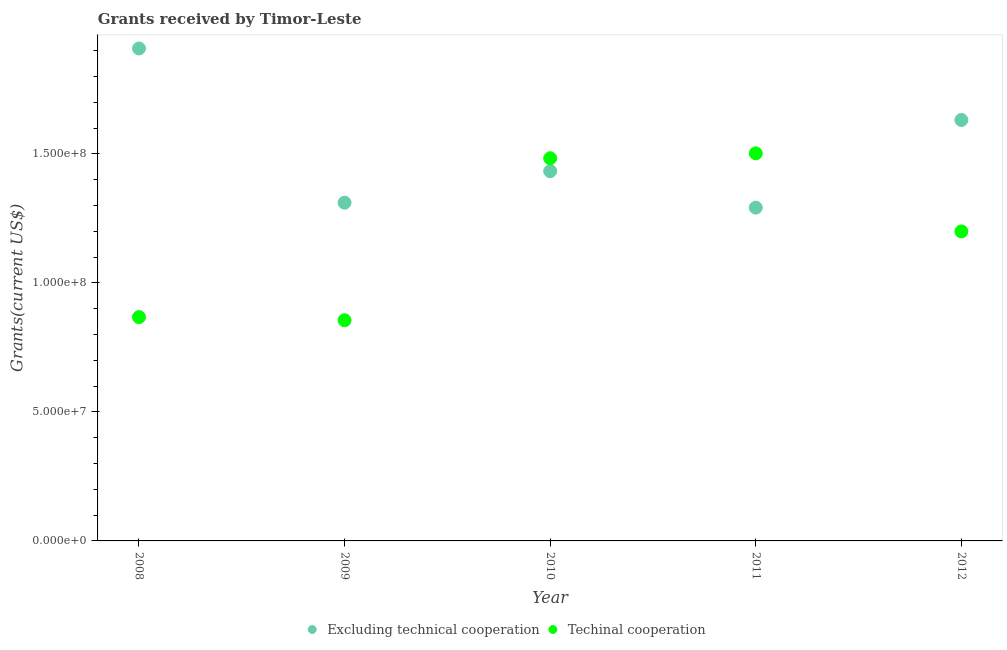Is the number of dotlines equal to the number of legend labels?
Your response must be concise. Yes. What is the amount of grants received(including technical cooperation) in 2011?
Ensure brevity in your answer.  1.50e+08. Across all years, what is the maximum amount of grants received(excluding technical cooperation)?
Offer a very short reply. 1.91e+08. Across all years, what is the minimum amount of grants received(including technical cooperation)?
Give a very brief answer. 8.55e+07. In which year was the amount of grants received(excluding technical cooperation) minimum?
Provide a short and direct response. 2011. What is the total amount of grants received(excluding technical cooperation) in the graph?
Offer a terse response. 7.57e+08. What is the difference between the amount of grants received(including technical cooperation) in 2008 and that in 2011?
Provide a succinct answer. -6.34e+07. What is the difference between the amount of grants received(including technical cooperation) in 2010 and the amount of grants received(excluding technical cooperation) in 2009?
Your answer should be compact. 1.72e+07. What is the average amount of grants received(including technical cooperation) per year?
Ensure brevity in your answer.  1.18e+08. In the year 2008, what is the difference between the amount of grants received(excluding technical cooperation) and amount of grants received(including technical cooperation)?
Keep it short and to the point. 1.04e+08. In how many years, is the amount of grants received(including technical cooperation) greater than 80000000 US$?
Offer a terse response. 5. What is the ratio of the amount of grants received(excluding technical cooperation) in 2008 to that in 2012?
Offer a terse response. 1.17. Is the amount of grants received(excluding technical cooperation) in 2008 less than that in 2011?
Make the answer very short. No. Is the difference between the amount of grants received(including technical cooperation) in 2009 and 2010 greater than the difference between the amount of grants received(excluding technical cooperation) in 2009 and 2010?
Your answer should be compact. No. What is the difference between the highest and the second highest amount of grants received(excluding technical cooperation)?
Provide a short and direct response. 2.77e+07. What is the difference between the highest and the lowest amount of grants received(excluding technical cooperation)?
Offer a very short reply. 6.17e+07. In how many years, is the amount of grants received(including technical cooperation) greater than the average amount of grants received(including technical cooperation) taken over all years?
Your response must be concise. 3. Does the amount of grants received(excluding technical cooperation) monotonically increase over the years?
Ensure brevity in your answer.  No. Is the amount of grants received(excluding technical cooperation) strictly less than the amount of grants received(including technical cooperation) over the years?
Your response must be concise. No. How many dotlines are there?
Provide a succinct answer. 2. How many years are there in the graph?
Your answer should be very brief. 5. Does the graph contain grids?
Your answer should be compact. No. Where does the legend appear in the graph?
Give a very brief answer. Bottom center. How are the legend labels stacked?
Provide a short and direct response. Horizontal. What is the title of the graph?
Provide a succinct answer. Grants received by Timor-Leste. What is the label or title of the Y-axis?
Provide a short and direct response. Grants(current US$). What is the Grants(current US$) of Excluding technical cooperation in 2008?
Provide a short and direct response. 1.91e+08. What is the Grants(current US$) in Techinal cooperation in 2008?
Make the answer very short. 8.67e+07. What is the Grants(current US$) in Excluding technical cooperation in 2009?
Offer a terse response. 1.31e+08. What is the Grants(current US$) in Techinal cooperation in 2009?
Ensure brevity in your answer.  8.55e+07. What is the Grants(current US$) of Excluding technical cooperation in 2010?
Your response must be concise. 1.43e+08. What is the Grants(current US$) of Techinal cooperation in 2010?
Offer a terse response. 1.48e+08. What is the Grants(current US$) of Excluding technical cooperation in 2011?
Keep it short and to the point. 1.29e+08. What is the Grants(current US$) of Techinal cooperation in 2011?
Make the answer very short. 1.50e+08. What is the Grants(current US$) of Excluding technical cooperation in 2012?
Provide a succinct answer. 1.63e+08. What is the Grants(current US$) of Techinal cooperation in 2012?
Give a very brief answer. 1.20e+08. Across all years, what is the maximum Grants(current US$) of Excluding technical cooperation?
Provide a short and direct response. 1.91e+08. Across all years, what is the maximum Grants(current US$) in Techinal cooperation?
Offer a terse response. 1.50e+08. Across all years, what is the minimum Grants(current US$) of Excluding technical cooperation?
Your answer should be very brief. 1.29e+08. Across all years, what is the minimum Grants(current US$) of Techinal cooperation?
Your response must be concise. 8.55e+07. What is the total Grants(current US$) in Excluding technical cooperation in the graph?
Your response must be concise. 7.57e+08. What is the total Grants(current US$) in Techinal cooperation in the graph?
Provide a short and direct response. 5.91e+08. What is the difference between the Grants(current US$) in Excluding technical cooperation in 2008 and that in 2009?
Provide a short and direct response. 5.98e+07. What is the difference between the Grants(current US$) in Techinal cooperation in 2008 and that in 2009?
Offer a very short reply. 1.21e+06. What is the difference between the Grants(current US$) in Excluding technical cooperation in 2008 and that in 2010?
Offer a very short reply. 4.75e+07. What is the difference between the Grants(current US$) of Techinal cooperation in 2008 and that in 2010?
Ensure brevity in your answer.  -6.16e+07. What is the difference between the Grants(current US$) in Excluding technical cooperation in 2008 and that in 2011?
Offer a very short reply. 6.17e+07. What is the difference between the Grants(current US$) in Techinal cooperation in 2008 and that in 2011?
Give a very brief answer. -6.34e+07. What is the difference between the Grants(current US$) of Excluding technical cooperation in 2008 and that in 2012?
Your response must be concise. 2.77e+07. What is the difference between the Grants(current US$) in Techinal cooperation in 2008 and that in 2012?
Your response must be concise. -3.32e+07. What is the difference between the Grants(current US$) of Excluding technical cooperation in 2009 and that in 2010?
Provide a short and direct response. -1.22e+07. What is the difference between the Grants(current US$) of Techinal cooperation in 2009 and that in 2010?
Offer a terse response. -6.28e+07. What is the difference between the Grants(current US$) of Excluding technical cooperation in 2009 and that in 2011?
Your response must be concise. 1.91e+06. What is the difference between the Grants(current US$) in Techinal cooperation in 2009 and that in 2011?
Offer a terse response. -6.47e+07. What is the difference between the Grants(current US$) of Excluding technical cooperation in 2009 and that in 2012?
Make the answer very short. -3.20e+07. What is the difference between the Grants(current US$) of Techinal cooperation in 2009 and that in 2012?
Your answer should be compact. -3.44e+07. What is the difference between the Grants(current US$) in Excluding technical cooperation in 2010 and that in 2011?
Ensure brevity in your answer.  1.41e+07. What is the difference between the Grants(current US$) in Techinal cooperation in 2010 and that in 2011?
Offer a terse response. -1.90e+06. What is the difference between the Grants(current US$) of Excluding technical cooperation in 2010 and that in 2012?
Your answer should be very brief. -1.98e+07. What is the difference between the Grants(current US$) in Techinal cooperation in 2010 and that in 2012?
Make the answer very short. 2.83e+07. What is the difference between the Grants(current US$) of Excluding technical cooperation in 2011 and that in 2012?
Your answer should be very brief. -3.40e+07. What is the difference between the Grants(current US$) of Techinal cooperation in 2011 and that in 2012?
Provide a short and direct response. 3.02e+07. What is the difference between the Grants(current US$) of Excluding technical cooperation in 2008 and the Grants(current US$) of Techinal cooperation in 2009?
Give a very brief answer. 1.05e+08. What is the difference between the Grants(current US$) of Excluding technical cooperation in 2008 and the Grants(current US$) of Techinal cooperation in 2010?
Ensure brevity in your answer.  4.26e+07. What is the difference between the Grants(current US$) of Excluding technical cooperation in 2008 and the Grants(current US$) of Techinal cooperation in 2011?
Offer a terse response. 4.06e+07. What is the difference between the Grants(current US$) in Excluding technical cooperation in 2008 and the Grants(current US$) in Techinal cooperation in 2012?
Offer a very short reply. 7.09e+07. What is the difference between the Grants(current US$) of Excluding technical cooperation in 2009 and the Grants(current US$) of Techinal cooperation in 2010?
Your response must be concise. -1.72e+07. What is the difference between the Grants(current US$) of Excluding technical cooperation in 2009 and the Grants(current US$) of Techinal cooperation in 2011?
Provide a succinct answer. -1.91e+07. What is the difference between the Grants(current US$) in Excluding technical cooperation in 2009 and the Grants(current US$) in Techinal cooperation in 2012?
Your response must be concise. 1.11e+07. What is the difference between the Grants(current US$) in Excluding technical cooperation in 2010 and the Grants(current US$) in Techinal cooperation in 2011?
Your answer should be very brief. -6.89e+06. What is the difference between the Grants(current US$) of Excluding technical cooperation in 2010 and the Grants(current US$) of Techinal cooperation in 2012?
Make the answer very short. 2.34e+07. What is the difference between the Grants(current US$) in Excluding technical cooperation in 2011 and the Grants(current US$) in Techinal cooperation in 2012?
Your answer should be very brief. 9.22e+06. What is the average Grants(current US$) of Excluding technical cooperation per year?
Offer a terse response. 1.51e+08. What is the average Grants(current US$) in Techinal cooperation per year?
Your answer should be very brief. 1.18e+08. In the year 2008, what is the difference between the Grants(current US$) in Excluding technical cooperation and Grants(current US$) in Techinal cooperation?
Provide a succinct answer. 1.04e+08. In the year 2009, what is the difference between the Grants(current US$) in Excluding technical cooperation and Grants(current US$) in Techinal cooperation?
Your answer should be compact. 4.56e+07. In the year 2010, what is the difference between the Grants(current US$) in Excluding technical cooperation and Grants(current US$) in Techinal cooperation?
Make the answer very short. -4.99e+06. In the year 2011, what is the difference between the Grants(current US$) in Excluding technical cooperation and Grants(current US$) in Techinal cooperation?
Give a very brief answer. -2.10e+07. In the year 2012, what is the difference between the Grants(current US$) of Excluding technical cooperation and Grants(current US$) of Techinal cooperation?
Make the answer very short. 4.32e+07. What is the ratio of the Grants(current US$) in Excluding technical cooperation in 2008 to that in 2009?
Keep it short and to the point. 1.46. What is the ratio of the Grants(current US$) of Techinal cooperation in 2008 to that in 2009?
Offer a terse response. 1.01. What is the ratio of the Grants(current US$) in Excluding technical cooperation in 2008 to that in 2010?
Your response must be concise. 1.33. What is the ratio of the Grants(current US$) of Techinal cooperation in 2008 to that in 2010?
Your answer should be compact. 0.58. What is the ratio of the Grants(current US$) in Excluding technical cooperation in 2008 to that in 2011?
Keep it short and to the point. 1.48. What is the ratio of the Grants(current US$) in Techinal cooperation in 2008 to that in 2011?
Offer a very short reply. 0.58. What is the ratio of the Grants(current US$) in Excluding technical cooperation in 2008 to that in 2012?
Give a very brief answer. 1.17. What is the ratio of the Grants(current US$) of Techinal cooperation in 2008 to that in 2012?
Your answer should be very brief. 0.72. What is the ratio of the Grants(current US$) of Excluding technical cooperation in 2009 to that in 2010?
Your response must be concise. 0.91. What is the ratio of the Grants(current US$) in Techinal cooperation in 2009 to that in 2010?
Your answer should be very brief. 0.58. What is the ratio of the Grants(current US$) of Excluding technical cooperation in 2009 to that in 2011?
Offer a terse response. 1.01. What is the ratio of the Grants(current US$) of Techinal cooperation in 2009 to that in 2011?
Keep it short and to the point. 0.57. What is the ratio of the Grants(current US$) of Excluding technical cooperation in 2009 to that in 2012?
Your response must be concise. 0.8. What is the ratio of the Grants(current US$) in Techinal cooperation in 2009 to that in 2012?
Give a very brief answer. 0.71. What is the ratio of the Grants(current US$) in Excluding technical cooperation in 2010 to that in 2011?
Ensure brevity in your answer.  1.11. What is the ratio of the Grants(current US$) in Techinal cooperation in 2010 to that in 2011?
Provide a short and direct response. 0.99. What is the ratio of the Grants(current US$) of Excluding technical cooperation in 2010 to that in 2012?
Provide a short and direct response. 0.88. What is the ratio of the Grants(current US$) of Techinal cooperation in 2010 to that in 2012?
Provide a succinct answer. 1.24. What is the ratio of the Grants(current US$) in Excluding technical cooperation in 2011 to that in 2012?
Your answer should be compact. 0.79. What is the ratio of the Grants(current US$) in Techinal cooperation in 2011 to that in 2012?
Your answer should be very brief. 1.25. What is the difference between the highest and the second highest Grants(current US$) in Excluding technical cooperation?
Keep it short and to the point. 2.77e+07. What is the difference between the highest and the second highest Grants(current US$) of Techinal cooperation?
Your response must be concise. 1.90e+06. What is the difference between the highest and the lowest Grants(current US$) in Excluding technical cooperation?
Your answer should be very brief. 6.17e+07. What is the difference between the highest and the lowest Grants(current US$) of Techinal cooperation?
Provide a succinct answer. 6.47e+07. 